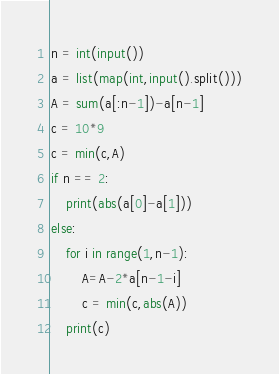Convert code to text. <code><loc_0><loc_0><loc_500><loc_500><_Python_>n = int(input())
a = list(map(int,input().split()))
A = sum(a[:n-1])-a[n-1]
c = 10*9
c = min(c,A)
if n == 2:
    print(abs(a[0]-a[1]))
else:
    for i in range(1,n-1):
        A=A-2*a[n-1-i]
        c = min(c,abs(A))
    print(c)
</code> 